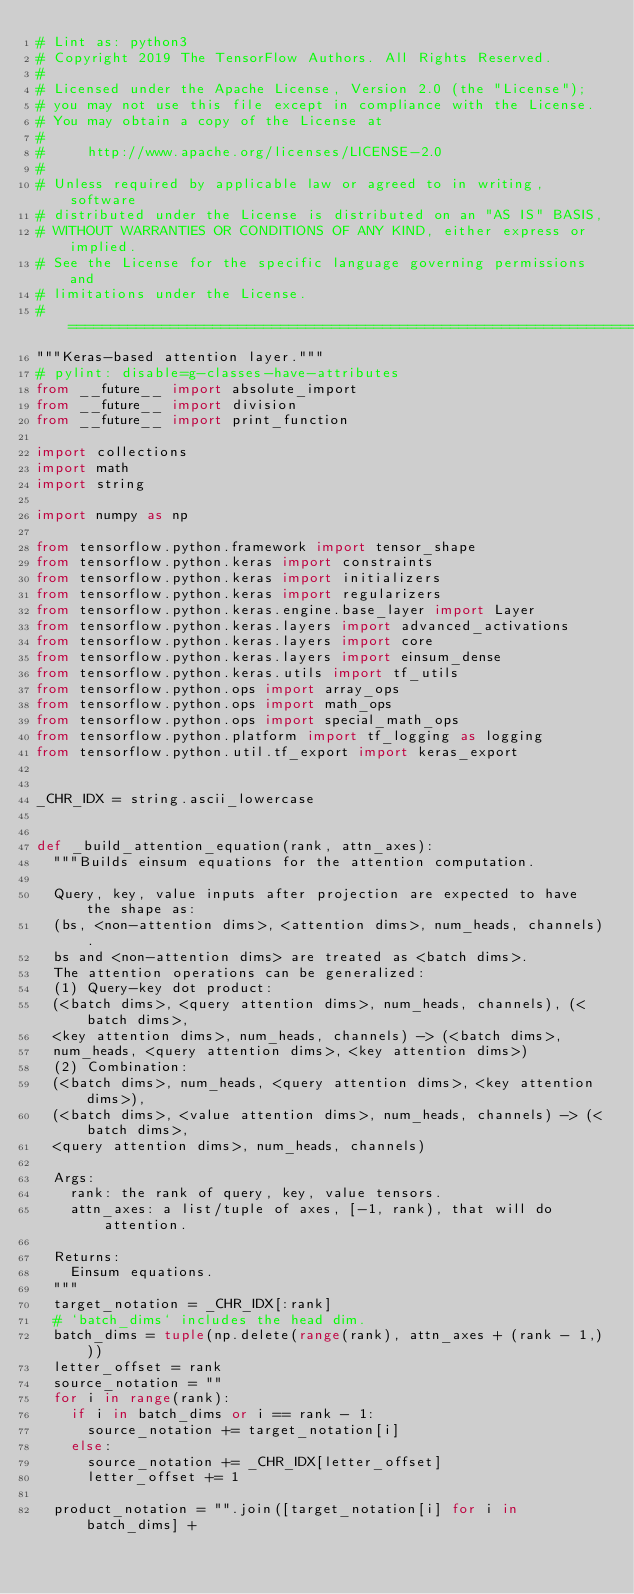<code> <loc_0><loc_0><loc_500><loc_500><_Python_># Lint as: python3
# Copyright 2019 The TensorFlow Authors. All Rights Reserved.
#
# Licensed under the Apache License, Version 2.0 (the "License");
# you may not use this file except in compliance with the License.
# You may obtain a copy of the License at
#
#     http://www.apache.org/licenses/LICENSE-2.0
#
# Unless required by applicable law or agreed to in writing, software
# distributed under the License is distributed on an "AS IS" BASIS,
# WITHOUT WARRANTIES OR CONDITIONS OF ANY KIND, either express or implied.
# See the License for the specific language governing permissions and
# limitations under the License.
# ==============================================================================
"""Keras-based attention layer."""
# pylint: disable=g-classes-have-attributes
from __future__ import absolute_import
from __future__ import division
from __future__ import print_function

import collections
import math
import string

import numpy as np

from tensorflow.python.framework import tensor_shape
from tensorflow.python.keras import constraints
from tensorflow.python.keras import initializers
from tensorflow.python.keras import regularizers
from tensorflow.python.keras.engine.base_layer import Layer
from tensorflow.python.keras.layers import advanced_activations
from tensorflow.python.keras.layers import core
from tensorflow.python.keras.layers import einsum_dense
from tensorflow.python.keras.utils import tf_utils
from tensorflow.python.ops import array_ops
from tensorflow.python.ops import math_ops
from tensorflow.python.ops import special_math_ops
from tensorflow.python.platform import tf_logging as logging
from tensorflow.python.util.tf_export import keras_export


_CHR_IDX = string.ascii_lowercase


def _build_attention_equation(rank, attn_axes):
  """Builds einsum equations for the attention computation.

  Query, key, value inputs after projection are expected to have the shape as:
  (bs, <non-attention dims>, <attention dims>, num_heads, channels).
  bs and <non-attention dims> are treated as <batch dims>.
  The attention operations can be generalized:
  (1) Query-key dot product:
  (<batch dims>, <query attention dims>, num_heads, channels), (<batch dims>,
  <key attention dims>, num_heads, channels) -> (<batch dims>,
  num_heads, <query attention dims>, <key attention dims>)
  (2) Combination:
  (<batch dims>, num_heads, <query attention dims>, <key attention dims>),
  (<batch dims>, <value attention dims>, num_heads, channels) -> (<batch dims>,
  <query attention dims>, num_heads, channels)

  Args:
    rank: the rank of query, key, value tensors.
    attn_axes: a list/tuple of axes, [-1, rank), that will do attention.

  Returns:
    Einsum equations.
  """
  target_notation = _CHR_IDX[:rank]
  # `batch_dims` includes the head dim.
  batch_dims = tuple(np.delete(range(rank), attn_axes + (rank - 1,)))
  letter_offset = rank
  source_notation = ""
  for i in range(rank):
    if i in batch_dims or i == rank - 1:
      source_notation += target_notation[i]
    else:
      source_notation += _CHR_IDX[letter_offset]
      letter_offset += 1

  product_notation = "".join([target_notation[i] for i in batch_dims] +</code> 